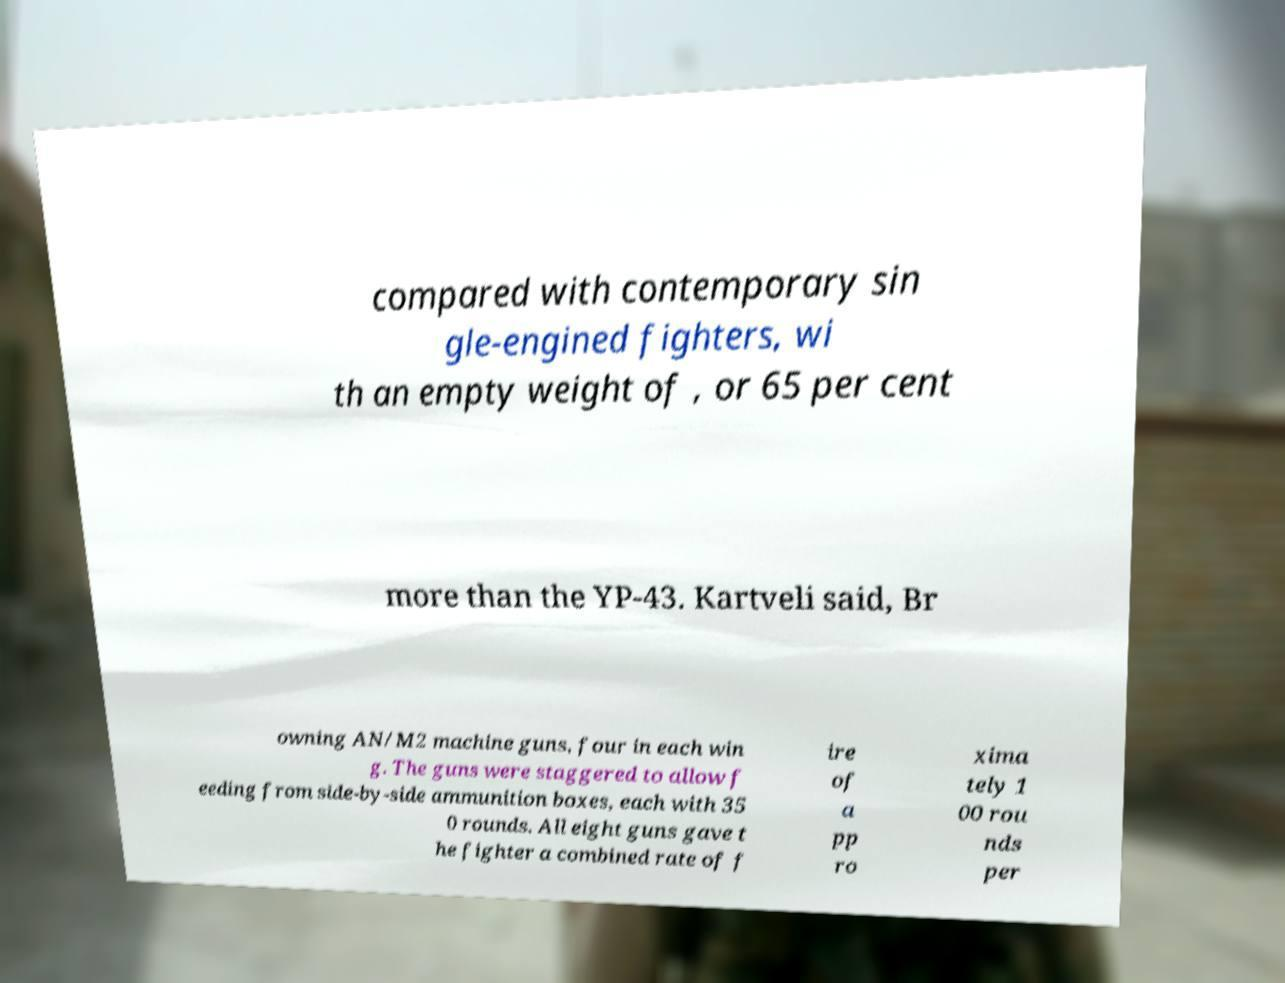What messages or text are displayed in this image? I need them in a readable, typed format. compared with contemporary sin gle-engined fighters, wi th an empty weight of , or 65 per cent more than the YP-43. Kartveli said, Br owning AN/M2 machine guns, four in each win g. The guns were staggered to allow f eeding from side-by-side ammunition boxes, each with 35 0 rounds. All eight guns gave t he fighter a combined rate of f ire of a pp ro xima tely 1 00 rou nds per 